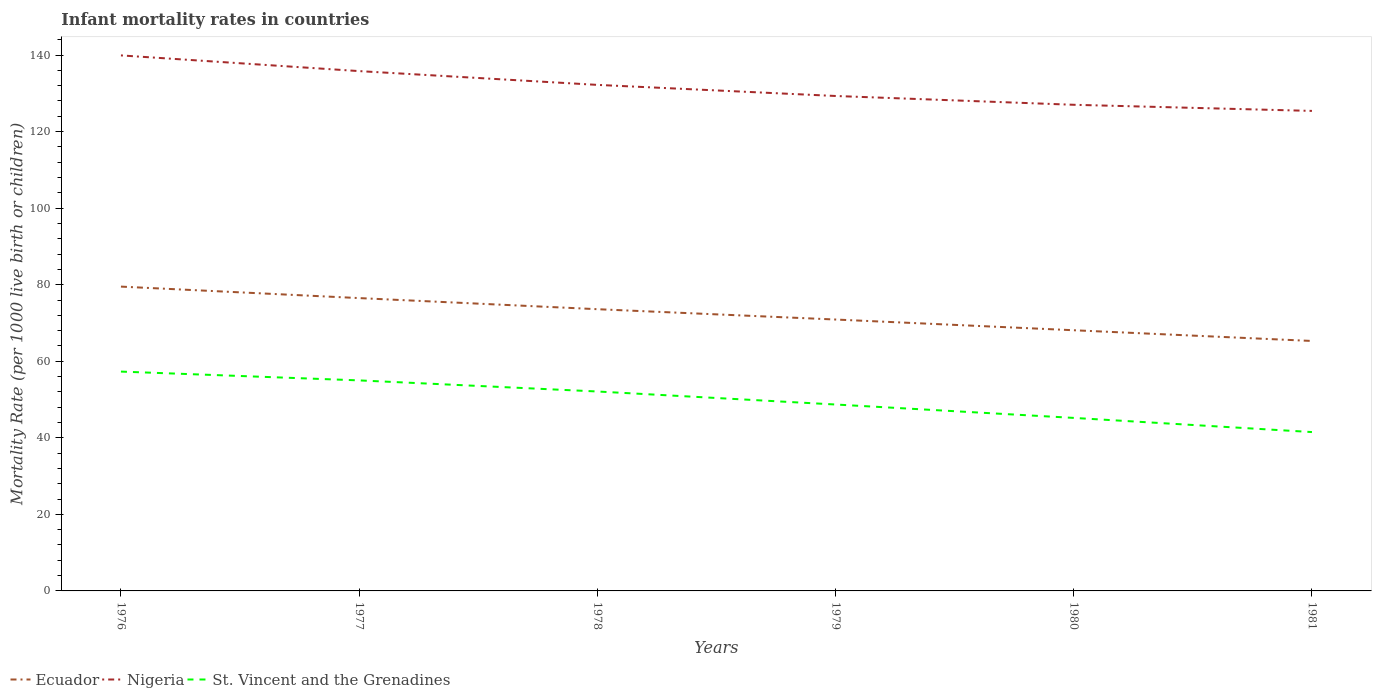How many different coloured lines are there?
Your answer should be compact. 3. Is the number of lines equal to the number of legend labels?
Offer a very short reply. Yes. Across all years, what is the maximum infant mortality rate in Nigeria?
Offer a very short reply. 125.4. In which year was the infant mortality rate in Ecuador maximum?
Keep it short and to the point. 1981. What is the total infant mortality rate in St. Vincent and the Grenadines in the graph?
Provide a short and direct response. 2.3. What is the difference between the highest and the second highest infant mortality rate in Ecuador?
Your answer should be compact. 14.2. What is the difference between the highest and the lowest infant mortality rate in Ecuador?
Provide a succinct answer. 3. Is the infant mortality rate in St. Vincent and the Grenadines strictly greater than the infant mortality rate in Ecuador over the years?
Provide a succinct answer. Yes. How many lines are there?
Give a very brief answer. 3. What is the difference between two consecutive major ticks on the Y-axis?
Your answer should be very brief. 20. Are the values on the major ticks of Y-axis written in scientific E-notation?
Provide a succinct answer. No. Does the graph contain any zero values?
Your answer should be very brief. No. Where does the legend appear in the graph?
Provide a short and direct response. Bottom left. How many legend labels are there?
Your answer should be very brief. 3. How are the legend labels stacked?
Give a very brief answer. Horizontal. What is the title of the graph?
Ensure brevity in your answer.  Infant mortality rates in countries. What is the label or title of the X-axis?
Your response must be concise. Years. What is the label or title of the Y-axis?
Your answer should be very brief. Mortality Rate (per 1000 live birth or children). What is the Mortality Rate (per 1000 live birth or children) of Ecuador in 1976?
Ensure brevity in your answer.  79.5. What is the Mortality Rate (per 1000 live birth or children) in Nigeria in 1976?
Offer a terse response. 139.9. What is the Mortality Rate (per 1000 live birth or children) in St. Vincent and the Grenadines in 1976?
Your answer should be very brief. 57.3. What is the Mortality Rate (per 1000 live birth or children) in Ecuador in 1977?
Provide a short and direct response. 76.5. What is the Mortality Rate (per 1000 live birth or children) in Nigeria in 1977?
Give a very brief answer. 135.8. What is the Mortality Rate (per 1000 live birth or children) of St. Vincent and the Grenadines in 1977?
Give a very brief answer. 55. What is the Mortality Rate (per 1000 live birth or children) in Ecuador in 1978?
Ensure brevity in your answer.  73.6. What is the Mortality Rate (per 1000 live birth or children) of Nigeria in 1978?
Keep it short and to the point. 132.2. What is the Mortality Rate (per 1000 live birth or children) in St. Vincent and the Grenadines in 1978?
Give a very brief answer. 52.1. What is the Mortality Rate (per 1000 live birth or children) in Ecuador in 1979?
Provide a short and direct response. 70.9. What is the Mortality Rate (per 1000 live birth or children) of Nigeria in 1979?
Your response must be concise. 129.3. What is the Mortality Rate (per 1000 live birth or children) in St. Vincent and the Grenadines in 1979?
Your response must be concise. 48.7. What is the Mortality Rate (per 1000 live birth or children) in Ecuador in 1980?
Offer a terse response. 68.1. What is the Mortality Rate (per 1000 live birth or children) in Nigeria in 1980?
Keep it short and to the point. 127. What is the Mortality Rate (per 1000 live birth or children) in St. Vincent and the Grenadines in 1980?
Your response must be concise. 45.2. What is the Mortality Rate (per 1000 live birth or children) of Ecuador in 1981?
Offer a very short reply. 65.3. What is the Mortality Rate (per 1000 live birth or children) of Nigeria in 1981?
Keep it short and to the point. 125.4. What is the Mortality Rate (per 1000 live birth or children) of St. Vincent and the Grenadines in 1981?
Provide a short and direct response. 41.5. Across all years, what is the maximum Mortality Rate (per 1000 live birth or children) of Ecuador?
Make the answer very short. 79.5. Across all years, what is the maximum Mortality Rate (per 1000 live birth or children) of Nigeria?
Your answer should be compact. 139.9. Across all years, what is the maximum Mortality Rate (per 1000 live birth or children) in St. Vincent and the Grenadines?
Give a very brief answer. 57.3. Across all years, what is the minimum Mortality Rate (per 1000 live birth or children) in Ecuador?
Offer a very short reply. 65.3. Across all years, what is the minimum Mortality Rate (per 1000 live birth or children) of Nigeria?
Make the answer very short. 125.4. Across all years, what is the minimum Mortality Rate (per 1000 live birth or children) in St. Vincent and the Grenadines?
Make the answer very short. 41.5. What is the total Mortality Rate (per 1000 live birth or children) of Ecuador in the graph?
Provide a succinct answer. 433.9. What is the total Mortality Rate (per 1000 live birth or children) of Nigeria in the graph?
Keep it short and to the point. 789.6. What is the total Mortality Rate (per 1000 live birth or children) in St. Vincent and the Grenadines in the graph?
Ensure brevity in your answer.  299.8. What is the difference between the Mortality Rate (per 1000 live birth or children) of Ecuador in 1976 and that in 1977?
Ensure brevity in your answer.  3. What is the difference between the Mortality Rate (per 1000 live birth or children) of St. Vincent and the Grenadines in 1976 and that in 1977?
Your answer should be compact. 2.3. What is the difference between the Mortality Rate (per 1000 live birth or children) of Ecuador in 1976 and that in 1978?
Offer a terse response. 5.9. What is the difference between the Mortality Rate (per 1000 live birth or children) in St. Vincent and the Grenadines in 1976 and that in 1978?
Your answer should be compact. 5.2. What is the difference between the Mortality Rate (per 1000 live birth or children) in Nigeria in 1976 and that in 1979?
Make the answer very short. 10.6. What is the difference between the Mortality Rate (per 1000 live birth or children) in Ecuador in 1976 and that in 1980?
Offer a very short reply. 11.4. What is the difference between the Mortality Rate (per 1000 live birth or children) in Nigeria in 1976 and that in 1980?
Offer a very short reply. 12.9. What is the difference between the Mortality Rate (per 1000 live birth or children) of Ecuador in 1976 and that in 1981?
Your answer should be very brief. 14.2. What is the difference between the Mortality Rate (per 1000 live birth or children) in Ecuador in 1977 and that in 1978?
Provide a succinct answer. 2.9. What is the difference between the Mortality Rate (per 1000 live birth or children) in Nigeria in 1977 and that in 1978?
Your answer should be compact. 3.6. What is the difference between the Mortality Rate (per 1000 live birth or children) in St. Vincent and the Grenadines in 1977 and that in 1978?
Your response must be concise. 2.9. What is the difference between the Mortality Rate (per 1000 live birth or children) of Ecuador in 1977 and that in 1979?
Your response must be concise. 5.6. What is the difference between the Mortality Rate (per 1000 live birth or children) in St. Vincent and the Grenadines in 1977 and that in 1979?
Offer a very short reply. 6.3. What is the difference between the Mortality Rate (per 1000 live birth or children) in Ecuador in 1978 and that in 1979?
Your response must be concise. 2.7. What is the difference between the Mortality Rate (per 1000 live birth or children) in Nigeria in 1978 and that in 1979?
Offer a very short reply. 2.9. What is the difference between the Mortality Rate (per 1000 live birth or children) in St. Vincent and the Grenadines in 1978 and that in 1979?
Provide a succinct answer. 3.4. What is the difference between the Mortality Rate (per 1000 live birth or children) in Ecuador in 1978 and that in 1980?
Your answer should be very brief. 5.5. What is the difference between the Mortality Rate (per 1000 live birth or children) of Nigeria in 1978 and that in 1980?
Ensure brevity in your answer.  5.2. What is the difference between the Mortality Rate (per 1000 live birth or children) in Ecuador in 1978 and that in 1981?
Offer a very short reply. 8.3. What is the difference between the Mortality Rate (per 1000 live birth or children) in Nigeria in 1978 and that in 1981?
Give a very brief answer. 6.8. What is the difference between the Mortality Rate (per 1000 live birth or children) of Nigeria in 1979 and that in 1980?
Keep it short and to the point. 2.3. What is the difference between the Mortality Rate (per 1000 live birth or children) in St. Vincent and the Grenadines in 1979 and that in 1980?
Your answer should be very brief. 3.5. What is the difference between the Mortality Rate (per 1000 live birth or children) in Ecuador in 1979 and that in 1981?
Your answer should be very brief. 5.6. What is the difference between the Mortality Rate (per 1000 live birth or children) in Nigeria in 1979 and that in 1981?
Ensure brevity in your answer.  3.9. What is the difference between the Mortality Rate (per 1000 live birth or children) in St. Vincent and the Grenadines in 1979 and that in 1981?
Your response must be concise. 7.2. What is the difference between the Mortality Rate (per 1000 live birth or children) in St. Vincent and the Grenadines in 1980 and that in 1981?
Your response must be concise. 3.7. What is the difference between the Mortality Rate (per 1000 live birth or children) in Ecuador in 1976 and the Mortality Rate (per 1000 live birth or children) in Nigeria in 1977?
Offer a very short reply. -56.3. What is the difference between the Mortality Rate (per 1000 live birth or children) of Nigeria in 1976 and the Mortality Rate (per 1000 live birth or children) of St. Vincent and the Grenadines in 1977?
Provide a short and direct response. 84.9. What is the difference between the Mortality Rate (per 1000 live birth or children) in Ecuador in 1976 and the Mortality Rate (per 1000 live birth or children) in Nigeria in 1978?
Give a very brief answer. -52.7. What is the difference between the Mortality Rate (per 1000 live birth or children) of Ecuador in 1976 and the Mortality Rate (per 1000 live birth or children) of St. Vincent and the Grenadines in 1978?
Make the answer very short. 27.4. What is the difference between the Mortality Rate (per 1000 live birth or children) in Nigeria in 1976 and the Mortality Rate (per 1000 live birth or children) in St. Vincent and the Grenadines in 1978?
Offer a very short reply. 87.8. What is the difference between the Mortality Rate (per 1000 live birth or children) of Ecuador in 1976 and the Mortality Rate (per 1000 live birth or children) of Nigeria in 1979?
Provide a short and direct response. -49.8. What is the difference between the Mortality Rate (per 1000 live birth or children) in Ecuador in 1976 and the Mortality Rate (per 1000 live birth or children) in St. Vincent and the Grenadines in 1979?
Ensure brevity in your answer.  30.8. What is the difference between the Mortality Rate (per 1000 live birth or children) in Nigeria in 1976 and the Mortality Rate (per 1000 live birth or children) in St. Vincent and the Grenadines in 1979?
Make the answer very short. 91.2. What is the difference between the Mortality Rate (per 1000 live birth or children) of Ecuador in 1976 and the Mortality Rate (per 1000 live birth or children) of Nigeria in 1980?
Your response must be concise. -47.5. What is the difference between the Mortality Rate (per 1000 live birth or children) in Ecuador in 1976 and the Mortality Rate (per 1000 live birth or children) in St. Vincent and the Grenadines in 1980?
Provide a succinct answer. 34.3. What is the difference between the Mortality Rate (per 1000 live birth or children) of Nigeria in 1976 and the Mortality Rate (per 1000 live birth or children) of St. Vincent and the Grenadines in 1980?
Offer a terse response. 94.7. What is the difference between the Mortality Rate (per 1000 live birth or children) in Ecuador in 1976 and the Mortality Rate (per 1000 live birth or children) in Nigeria in 1981?
Your answer should be very brief. -45.9. What is the difference between the Mortality Rate (per 1000 live birth or children) of Ecuador in 1976 and the Mortality Rate (per 1000 live birth or children) of St. Vincent and the Grenadines in 1981?
Provide a succinct answer. 38. What is the difference between the Mortality Rate (per 1000 live birth or children) of Nigeria in 1976 and the Mortality Rate (per 1000 live birth or children) of St. Vincent and the Grenadines in 1981?
Provide a succinct answer. 98.4. What is the difference between the Mortality Rate (per 1000 live birth or children) of Ecuador in 1977 and the Mortality Rate (per 1000 live birth or children) of Nigeria in 1978?
Offer a terse response. -55.7. What is the difference between the Mortality Rate (per 1000 live birth or children) in Ecuador in 1977 and the Mortality Rate (per 1000 live birth or children) in St. Vincent and the Grenadines in 1978?
Offer a very short reply. 24.4. What is the difference between the Mortality Rate (per 1000 live birth or children) of Nigeria in 1977 and the Mortality Rate (per 1000 live birth or children) of St. Vincent and the Grenadines in 1978?
Give a very brief answer. 83.7. What is the difference between the Mortality Rate (per 1000 live birth or children) of Ecuador in 1977 and the Mortality Rate (per 1000 live birth or children) of Nigeria in 1979?
Ensure brevity in your answer.  -52.8. What is the difference between the Mortality Rate (per 1000 live birth or children) of Ecuador in 1977 and the Mortality Rate (per 1000 live birth or children) of St. Vincent and the Grenadines in 1979?
Give a very brief answer. 27.8. What is the difference between the Mortality Rate (per 1000 live birth or children) in Nigeria in 1977 and the Mortality Rate (per 1000 live birth or children) in St. Vincent and the Grenadines in 1979?
Make the answer very short. 87.1. What is the difference between the Mortality Rate (per 1000 live birth or children) of Ecuador in 1977 and the Mortality Rate (per 1000 live birth or children) of Nigeria in 1980?
Ensure brevity in your answer.  -50.5. What is the difference between the Mortality Rate (per 1000 live birth or children) of Ecuador in 1977 and the Mortality Rate (per 1000 live birth or children) of St. Vincent and the Grenadines in 1980?
Your answer should be very brief. 31.3. What is the difference between the Mortality Rate (per 1000 live birth or children) of Nigeria in 1977 and the Mortality Rate (per 1000 live birth or children) of St. Vincent and the Grenadines in 1980?
Keep it short and to the point. 90.6. What is the difference between the Mortality Rate (per 1000 live birth or children) in Ecuador in 1977 and the Mortality Rate (per 1000 live birth or children) in Nigeria in 1981?
Make the answer very short. -48.9. What is the difference between the Mortality Rate (per 1000 live birth or children) of Ecuador in 1977 and the Mortality Rate (per 1000 live birth or children) of St. Vincent and the Grenadines in 1981?
Your response must be concise. 35. What is the difference between the Mortality Rate (per 1000 live birth or children) in Nigeria in 1977 and the Mortality Rate (per 1000 live birth or children) in St. Vincent and the Grenadines in 1981?
Your answer should be compact. 94.3. What is the difference between the Mortality Rate (per 1000 live birth or children) in Ecuador in 1978 and the Mortality Rate (per 1000 live birth or children) in Nigeria in 1979?
Provide a succinct answer. -55.7. What is the difference between the Mortality Rate (per 1000 live birth or children) in Ecuador in 1978 and the Mortality Rate (per 1000 live birth or children) in St. Vincent and the Grenadines in 1979?
Your response must be concise. 24.9. What is the difference between the Mortality Rate (per 1000 live birth or children) in Nigeria in 1978 and the Mortality Rate (per 1000 live birth or children) in St. Vincent and the Grenadines in 1979?
Your response must be concise. 83.5. What is the difference between the Mortality Rate (per 1000 live birth or children) of Ecuador in 1978 and the Mortality Rate (per 1000 live birth or children) of Nigeria in 1980?
Offer a terse response. -53.4. What is the difference between the Mortality Rate (per 1000 live birth or children) in Ecuador in 1978 and the Mortality Rate (per 1000 live birth or children) in St. Vincent and the Grenadines in 1980?
Provide a succinct answer. 28.4. What is the difference between the Mortality Rate (per 1000 live birth or children) in Nigeria in 1978 and the Mortality Rate (per 1000 live birth or children) in St. Vincent and the Grenadines in 1980?
Your response must be concise. 87. What is the difference between the Mortality Rate (per 1000 live birth or children) in Ecuador in 1978 and the Mortality Rate (per 1000 live birth or children) in Nigeria in 1981?
Your answer should be compact. -51.8. What is the difference between the Mortality Rate (per 1000 live birth or children) of Ecuador in 1978 and the Mortality Rate (per 1000 live birth or children) of St. Vincent and the Grenadines in 1981?
Keep it short and to the point. 32.1. What is the difference between the Mortality Rate (per 1000 live birth or children) of Nigeria in 1978 and the Mortality Rate (per 1000 live birth or children) of St. Vincent and the Grenadines in 1981?
Your answer should be compact. 90.7. What is the difference between the Mortality Rate (per 1000 live birth or children) of Ecuador in 1979 and the Mortality Rate (per 1000 live birth or children) of Nigeria in 1980?
Your answer should be very brief. -56.1. What is the difference between the Mortality Rate (per 1000 live birth or children) in Ecuador in 1979 and the Mortality Rate (per 1000 live birth or children) in St. Vincent and the Grenadines in 1980?
Give a very brief answer. 25.7. What is the difference between the Mortality Rate (per 1000 live birth or children) of Nigeria in 1979 and the Mortality Rate (per 1000 live birth or children) of St. Vincent and the Grenadines in 1980?
Ensure brevity in your answer.  84.1. What is the difference between the Mortality Rate (per 1000 live birth or children) in Ecuador in 1979 and the Mortality Rate (per 1000 live birth or children) in Nigeria in 1981?
Provide a short and direct response. -54.5. What is the difference between the Mortality Rate (per 1000 live birth or children) of Ecuador in 1979 and the Mortality Rate (per 1000 live birth or children) of St. Vincent and the Grenadines in 1981?
Give a very brief answer. 29.4. What is the difference between the Mortality Rate (per 1000 live birth or children) of Nigeria in 1979 and the Mortality Rate (per 1000 live birth or children) of St. Vincent and the Grenadines in 1981?
Make the answer very short. 87.8. What is the difference between the Mortality Rate (per 1000 live birth or children) in Ecuador in 1980 and the Mortality Rate (per 1000 live birth or children) in Nigeria in 1981?
Give a very brief answer. -57.3. What is the difference between the Mortality Rate (per 1000 live birth or children) in Ecuador in 1980 and the Mortality Rate (per 1000 live birth or children) in St. Vincent and the Grenadines in 1981?
Your answer should be very brief. 26.6. What is the difference between the Mortality Rate (per 1000 live birth or children) in Nigeria in 1980 and the Mortality Rate (per 1000 live birth or children) in St. Vincent and the Grenadines in 1981?
Offer a terse response. 85.5. What is the average Mortality Rate (per 1000 live birth or children) of Ecuador per year?
Provide a succinct answer. 72.32. What is the average Mortality Rate (per 1000 live birth or children) of Nigeria per year?
Offer a terse response. 131.6. What is the average Mortality Rate (per 1000 live birth or children) in St. Vincent and the Grenadines per year?
Ensure brevity in your answer.  49.97. In the year 1976, what is the difference between the Mortality Rate (per 1000 live birth or children) of Ecuador and Mortality Rate (per 1000 live birth or children) of Nigeria?
Your answer should be compact. -60.4. In the year 1976, what is the difference between the Mortality Rate (per 1000 live birth or children) in Ecuador and Mortality Rate (per 1000 live birth or children) in St. Vincent and the Grenadines?
Make the answer very short. 22.2. In the year 1976, what is the difference between the Mortality Rate (per 1000 live birth or children) in Nigeria and Mortality Rate (per 1000 live birth or children) in St. Vincent and the Grenadines?
Offer a very short reply. 82.6. In the year 1977, what is the difference between the Mortality Rate (per 1000 live birth or children) in Ecuador and Mortality Rate (per 1000 live birth or children) in Nigeria?
Make the answer very short. -59.3. In the year 1977, what is the difference between the Mortality Rate (per 1000 live birth or children) in Ecuador and Mortality Rate (per 1000 live birth or children) in St. Vincent and the Grenadines?
Make the answer very short. 21.5. In the year 1977, what is the difference between the Mortality Rate (per 1000 live birth or children) in Nigeria and Mortality Rate (per 1000 live birth or children) in St. Vincent and the Grenadines?
Offer a terse response. 80.8. In the year 1978, what is the difference between the Mortality Rate (per 1000 live birth or children) of Ecuador and Mortality Rate (per 1000 live birth or children) of Nigeria?
Your response must be concise. -58.6. In the year 1978, what is the difference between the Mortality Rate (per 1000 live birth or children) of Ecuador and Mortality Rate (per 1000 live birth or children) of St. Vincent and the Grenadines?
Ensure brevity in your answer.  21.5. In the year 1978, what is the difference between the Mortality Rate (per 1000 live birth or children) in Nigeria and Mortality Rate (per 1000 live birth or children) in St. Vincent and the Grenadines?
Provide a succinct answer. 80.1. In the year 1979, what is the difference between the Mortality Rate (per 1000 live birth or children) of Ecuador and Mortality Rate (per 1000 live birth or children) of Nigeria?
Ensure brevity in your answer.  -58.4. In the year 1979, what is the difference between the Mortality Rate (per 1000 live birth or children) of Ecuador and Mortality Rate (per 1000 live birth or children) of St. Vincent and the Grenadines?
Give a very brief answer. 22.2. In the year 1979, what is the difference between the Mortality Rate (per 1000 live birth or children) of Nigeria and Mortality Rate (per 1000 live birth or children) of St. Vincent and the Grenadines?
Offer a very short reply. 80.6. In the year 1980, what is the difference between the Mortality Rate (per 1000 live birth or children) of Ecuador and Mortality Rate (per 1000 live birth or children) of Nigeria?
Make the answer very short. -58.9. In the year 1980, what is the difference between the Mortality Rate (per 1000 live birth or children) in Ecuador and Mortality Rate (per 1000 live birth or children) in St. Vincent and the Grenadines?
Offer a very short reply. 22.9. In the year 1980, what is the difference between the Mortality Rate (per 1000 live birth or children) in Nigeria and Mortality Rate (per 1000 live birth or children) in St. Vincent and the Grenadines?
Provide a short and direct response. 81.8. In the year 1981, what is the difference between the Mortality Rate (per 1000 live birth or children) in Ecuador and Mortality Rate (per 1000 live birth or children) in Nigeria?
Make the answer very short. -60.1. In the year 1981, what is the difference between the Mortality Rate (per 1000 live birth or children) in Ecuador and Mortality Rate (per 1000 live birth or children) in St. Vincent and the Grenadines?
Offer a very short reply. 23.8. In the year 1981, what is the difference between the Mortality Rate (per 1000 live birth or children) in Nigeria and Mortality Rate (per 1000 live birth or children) in St. Vincent and the Grenadines?
Your response must be concise. 83.9. What is the ratio of the Mortality Rate (per 1000 live birth or children) of Ecuador in 1976 to that in 1977?
Offer a very short reply. 1.04. What is the ratio of the Mortality Rate (per 1000 live birth or children) of Nigeria in 1976 to that in 1977?
Provide a succinct answer. 1.03. What is the ratio of the Mortality Rate (per 1000 live birth or children) in St. Vincent and the Grenadines in 1976 to that in 1977?
Keep it short and to the point. 1.04. What is the ratio of the Mortality Rate (per 1000 live birth or children) in Ecuador in 1976 to that in 1978?
Provide a succinct answer. 1.08. What is the ratio of the Mortality Rate (per 1000 live birth or children) in Nigeria in 1976 to that in 1978?
Your answer should be compact. 1.06. What is the ratio of the Mortality Rate (per 1000 live birth or children) of St. Vincent and the Grenadines in 1976 to that in 1978?
Offer a very short reply. 1.1. What is the ratio of the Mortality Rate (per 1000 live birth or children) of Ecuador in 1976 to that in 1979?
Offer a terse response. 1.12. What is the ratio of the Mortality Rate (per 1000 live birth or children) in Nigeria in 1976 to that in 1979?
Provide a succinct answer. 1.08. What is the ratio of the Mortality Rate (per 1000 live birth or children) of St. Vincent and the Grenadines in 1976 to that in 1979?
Give a very brief answer. 1.18. What is the ratio of the Mortality Rate (per 1000 live birth or children) in Ecuador in 1976 to that in 1980?
Offer a terse response. 1.17. What is the ratio of the Mortality Rate (per 1000 live birth or children) of Nigeria in 1976 to that in 1980?
Give a very brief answer. 1.1. What is the ratio of the Mortality Rate (per 1000 live birth or children) in St. Vincent and the Grenadines in 1976 to that in 1980?
Make the answer very short. 1.27. What is the ratio of the Mortality Rate (per 1000 live birth or children) in Ecuador in 1976 to that in 1981?
Make the answer very short. 1.22. What is the ratio of the Mortality Rate (per 1000 live birth or children) of Nigeria in 1976 to that in 1981?
Provide a succinct answer. 1.12. What is the ratio of the Mortality Rate (per 1000 live birth or children) in St. Vincent and the Grenadines in 1976 to that in 1981?
Ensure brevity in your answer.  1.38. What is the ratio of the Mortality Rate (per 1000 live birth or children) in Ecuador in 1977 to that in 1978?
Give a very brief answer. 1.04. What is the ratio of the Mortality Rate (per 1000 live birth or children) of Nigeria in 1977 to that in 1978?
Keep it short and to the point. 1.03. What is the ratio of the Mortality Rate (per 1000 live birth or children) of St. Vincent and the Grenadines in 1977 to that in 1978?
Ensure brevity in your answer.  1.06. What is the ratio of the Mortality Rate (per 1000 live birth or children) in Ecuador in 1977 to that in 1979?
Your response must be concise. 1.08. What is the ratio of the Mortality Rate (per 1000 live birth or children) of Nigeria in 1977 to that in 1979?
Provide a short and direct response. 1.05. What is the ratio of the Mortality Rate (per 1000 live birth or children) of St. Vincent and the Grenadines in 1977 to that in 1979?
Your answer should be very brief. 1.13. What is the ratio of the Mortality Rate (per 1000 live birth or children) of Ecuador in 1977 to that in 1980?
Your response must be concise. 1.12. What is the ratio of the Mortality Rate (per 1000 live birth or children) of Nigeria in 1977 to that in 1980?
Your response must be concise. 1.07. What is the ratio of the Mortality Rate (per 1000 live birth or children) in St. Vincent and the Grenadines in 1977 to that in 1980?
Your response must be concise. 1.22. What is the ratio of the Mortality Rate (per 1000 live birth or children) of Ecuador in 1977 to that in 1981?
Provide a succinct answer. 1.17. What is the ratio of the Mortality Rate (per 1000 live birth or children) of Nigeria in 1977 to that in 1981?
Ensure brevity in your answer.  1.08. What is the ratio of the Mortality Rate (per 1000 live birth or children) of St. Vincent and the Grenadines in 1977 to that in 1981?
Offer a terse response. 1.33. What is the ratio of the Mortality Rate (per 1000 live birth or children) of Ecuador in 1978 to that in 1979?
Your response must be concise. 1.04. What is the ratio of the Mortality Rate (per 1000 live birth or children) in Nigeria in 1978 to that in 1979?
Keep it short and to the point. 1.02. What is the ratio of the Mortality Rate (per 1000 live birth or children) of St. Vincent and the Grenadines in 1978 to that in 1979?
Give a very brief answer. 1.07. What is the ratio of the Mortality Rate (per 1000 live birth or children) in Ecuador in 1978 to that in 1980?
Give a very brief answer. 1.08. What is the ratio of the Mortality Rate (per 1000 live birth or children) of Nigeria in 1978 to that in 1980?
Your response must be concise. 1.04. What is the ratio of the Mortality Rate (per 1000 live birth or children) in St. Vincent and the Grenadines in 1978 to that in 1980?
Offer a terse response. 1.15. What is the ratio of the Mortality Rate (per 1000 live birth or children) in Ecuador in 1978 to that in 1981?
Keep it short and to the point. 1.13. What is the ratio of the Mortality Rate (per 1000 live birth or children) in Nigeria in 1978 to that in 1981?
Offer a terse response. 1.05. What is the ratio of the Mortality Rate (per 1000 live birth or children) of St. Vincent and the Grenadines in 1978 to that in 1981?
Ensure brevity in your answer.  1.26. What is the ratio of the Mortality Rate (per 1000 live birth or children) in Ecuador in 1979 to that in 1980?
Provide a succinct answer. 1.04. What is the ratio of the Mortality Rate (per 1000 live birth or children) in Nigeria in 1979 to that in 1980?
Keep it short and to the point. 1.02. What is the ratio of the Mortality Rate (per 1000 live birth or children) of St. Vincent and the Grenadines in 1979 to that in 1980?
Keep it short and to the point. 1.08. What is the ratio of the Mortality Rate (per 1000 live birth or children) in Ecuador in 1979 to that in 1981?
Your response must be concise. 1.09. What is the ratio of the Mortality Rate (per 1000 live birth or children) of Nigeria in 1979 to that in 1981?
Provide a short and direct response. 1.03. What is the ratio of the Mortality Rate (per 1000 live birth or children) of St. Vincent and the Grenadines in 1979 to that in 1981?
Your answer should be compact. 1.17. What is the ratio of the Mortality Rate (per 1000 live birth or children) in Ecuador in 1980 to that in 1981?
Provide a short and direct response. 1.04. What is the ratio of the Mortality Rate (per 1000 live birth or children) in Nigeria in 1980 to that in 1981?
Your answer should be very brief. 1.01. What is the ratio of the Mortality Rate (per 1000 live birth or children) in St. Vincent and the Grenadines in 1980 to that in 1981?
Make the answer very short. 1.09. What is the difference between the highest and the second highest Mortality Rate (per 1000 live birth or children) of St. Vincent and the Grenadines?
Keep it short and to the point. 2.3. 